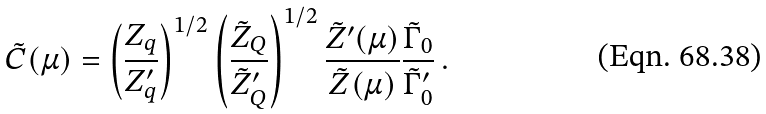Convert formula to latex. <formula><loc_0><loc_0><loc_500><loc_500>\tilde { C } ( \mu ) = \left ( \frac { Z _ { q } } { Z _ { q } ^ { \prime } } \right ) ^ { 1 / 2 } \left ( \frac { \tilde { Z } _ { Q } } { \tilde { Z } _ { Q } ^ { \prime } } \right ) ^ { 1 / 2 } \frac { \tilde { Z } ^ { \prime } ( \mu ) } { \tilde { Z } ( \mu ) } \frac { \tilde { \Gamma } _ { 0 } } { \tilde { \Gamma } _ { 0 } ^ { \prime } } \, .</formula> 